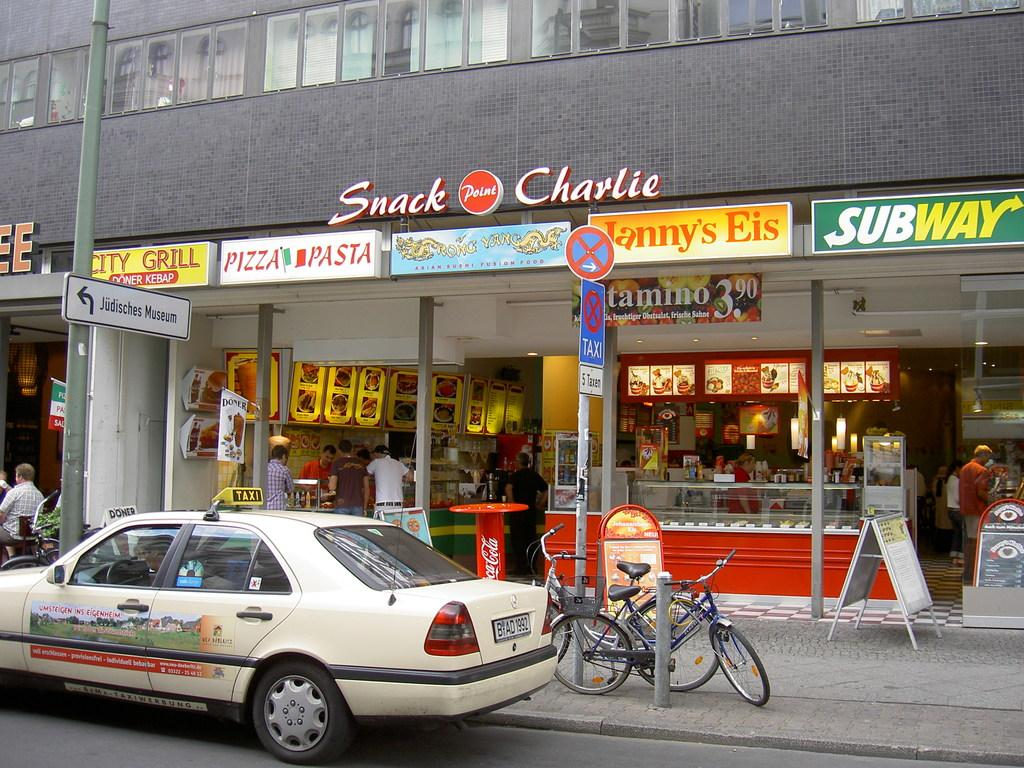<image>
Create a compact narrative representing the image presented. A car in front of Snack Charlie cafe 